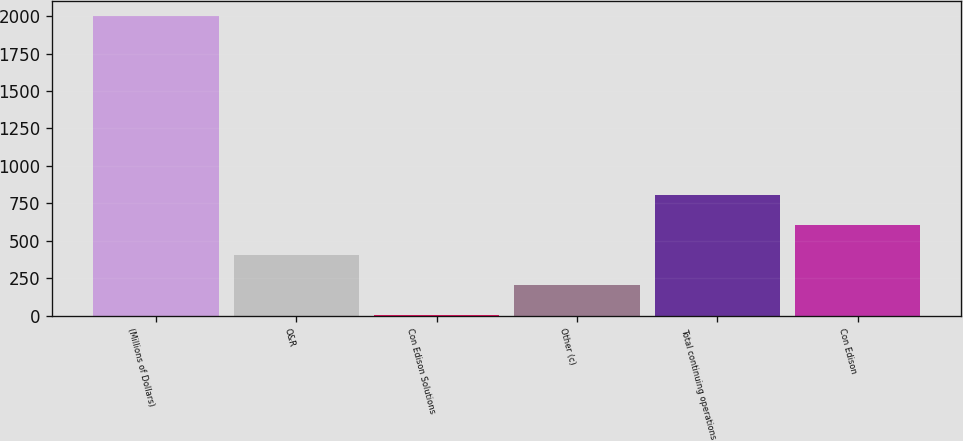Convert chart to OTSL. <chart><loc_0><loc_0><loc_500><loc_500><bar_chart><fcel>(Millions of Dollars)<fcel>O&R<fcel>Con Edison Solutions<fcel>Other (c)<fcel>Total continuing operations<fcel>Con Edison<nl><fcel>2004<fcel>403.2<fcel>3<fcel>203.1<fcel>803.4<fcel>603.3<nl></chart> 